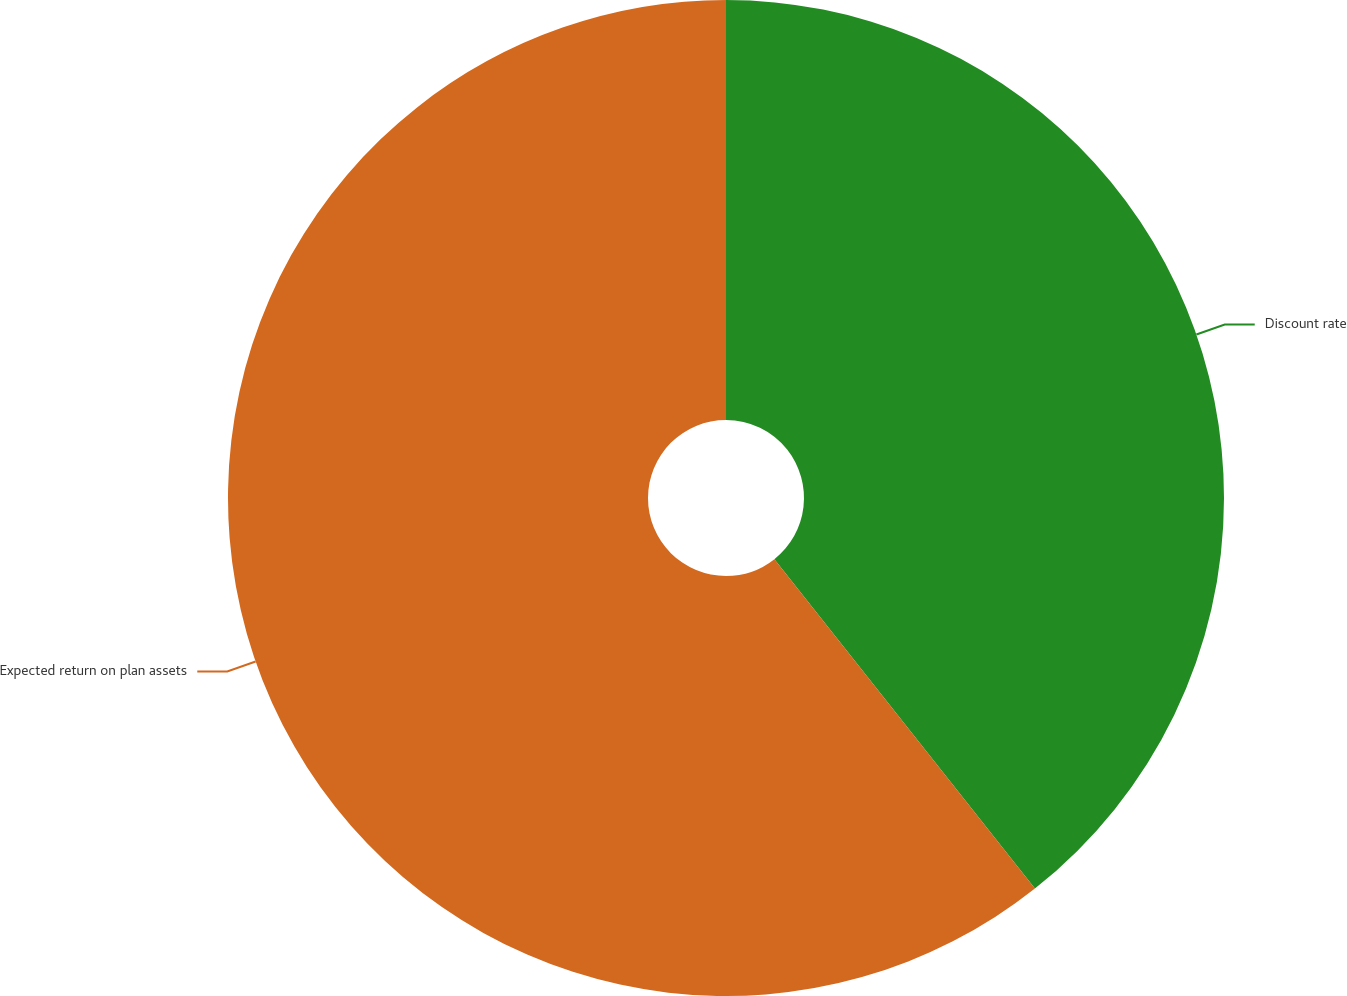Convert chart to OTSL. <chart><loc_0><loc_0><loc_500><loc_500><pie_chart><fcel>Discount rate<fcel>Expected return on plan assets<nl><fcel>39.35%<fcel>60.65%<nl></chart> 